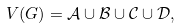<formula> <loc_0><loc_0><loc_500><loc_500>V ( G ) = \mathcal { A } \cup \mathcal { B } \cup \mathcal { C } \cup \mathcal { D } ,</formula> 